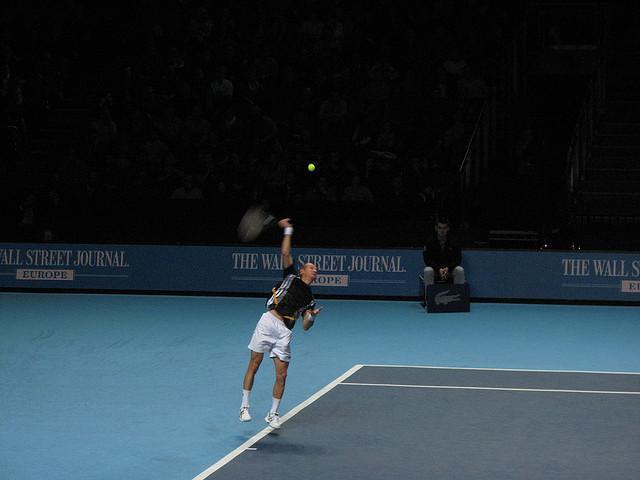How many hands does the gold-rimmed clock have?
Give a very brief answer. 0. 